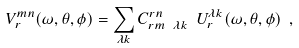Convert formula to latex. <formula><loc_0><loc_0><loc_500><loc_500>V _ { r } ^ { m n } ( \omega , \theta , \phi ) = \sum _ { \lambda k } C ^ { r n } _ { r m \ \lambda k } \ U _ { r } ^ { \lambda k } ( \omega , \theta , \phi ) \ ,</formula> 